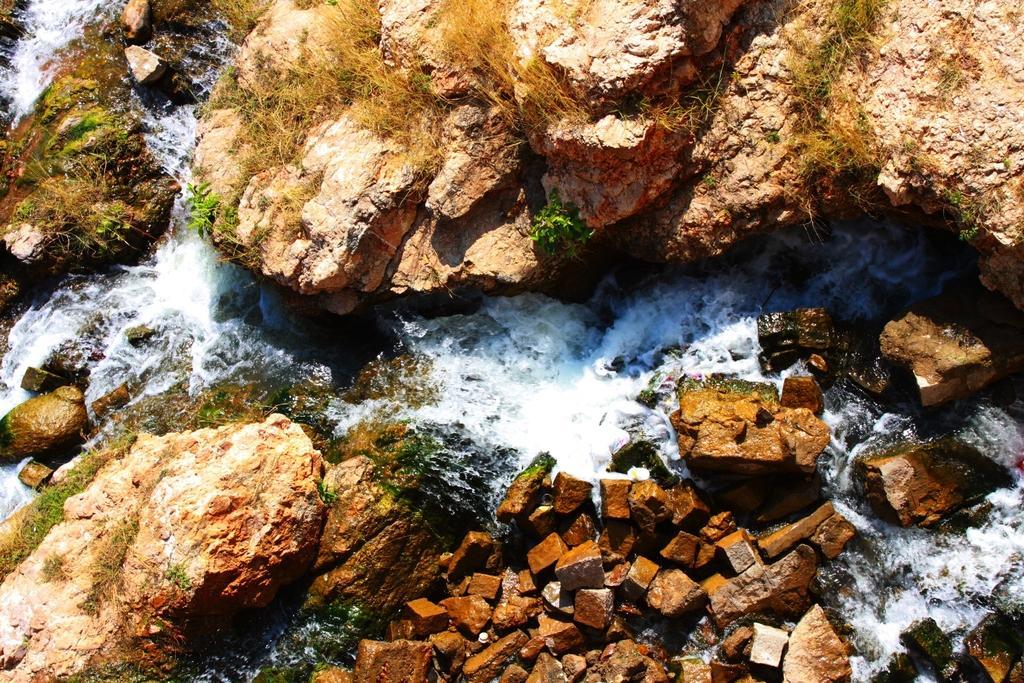Can you describe this image briefly? In this image we can see rocks. There is water flowing. Also there are few plants. 